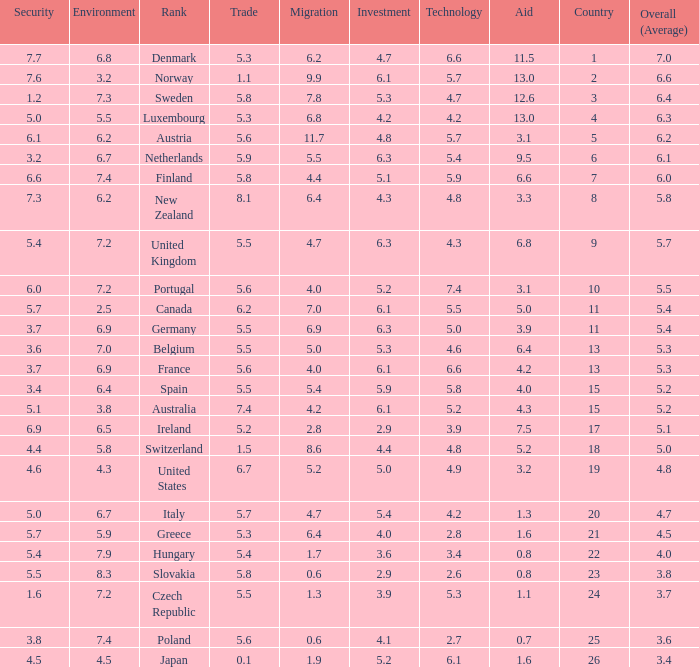What is the environment rating of the country with an overall average rating of 4.7? 6.7. 